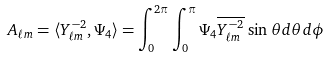Convert formula to latex. <formula><loc_0><loc_0><loc_500><loc_500>A _ { \ell m } = \langle Y ^ { - 2 } _ { \ell m } , \Psi _ { 4 } \rangle = \int _ { 0 } ^ { 2 \pi } \int _ { 0 } ^ { \pi } \Psi _ { 4 } \overline { Y ^ { - 2 } _ { \ell m } } \, \sin \theta d \theta d \phi</formula> 